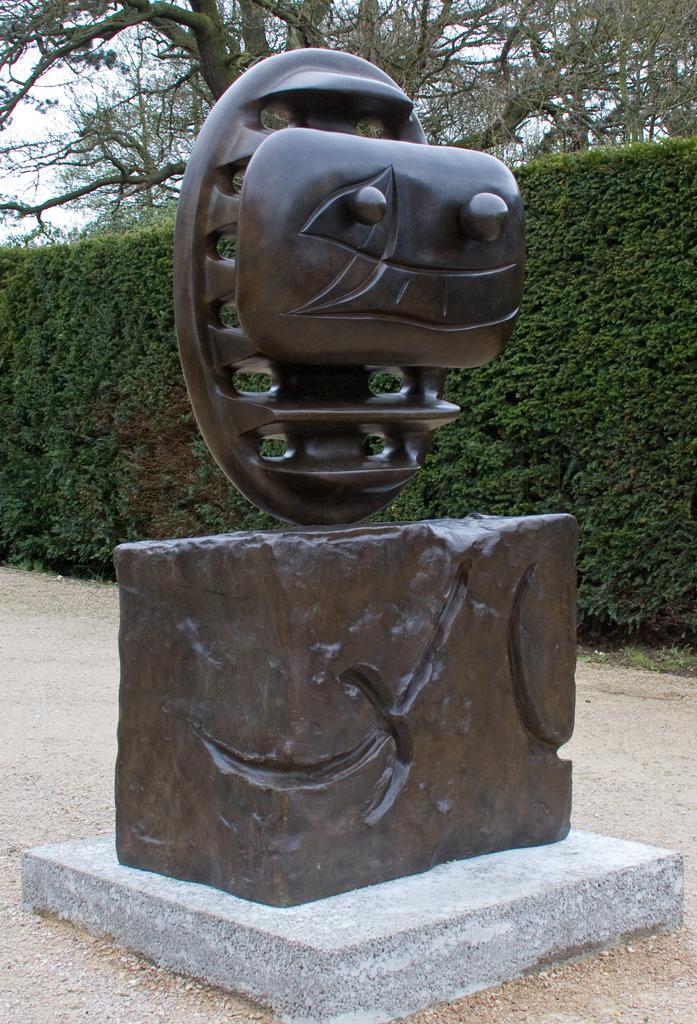Can you describe this image briefly? In this image I can see a sculpture on the road. In the background I can see plants, trees and the sky. This image is taken during a day. 